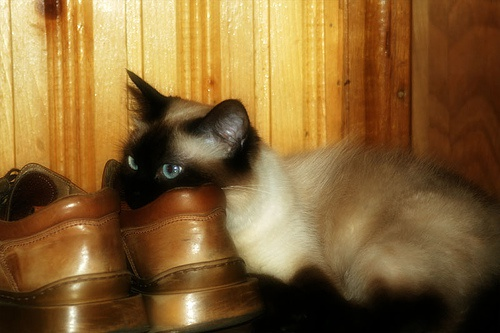Describe the objects in this image and their specific colors. I can see a cat in beige, black, olive, and tan tones in this image. 